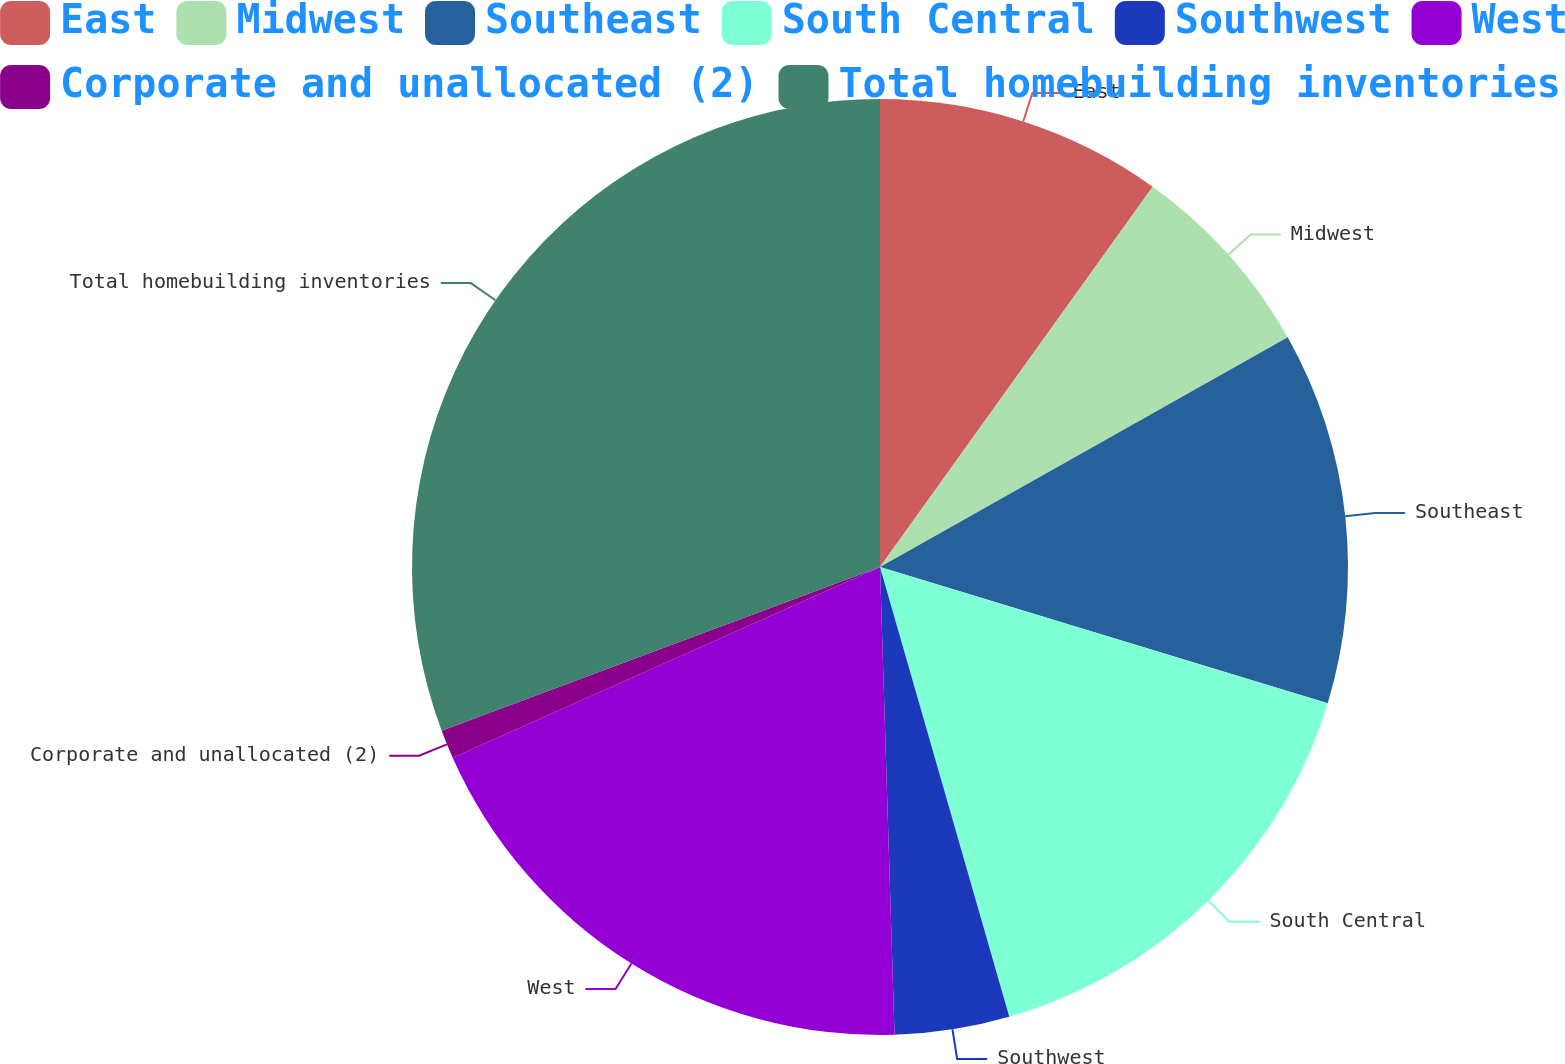<chart> <loc_0><loc_0><loc_500><loc_500><pie_chart><fcel>East<fcel>Midwest<fcel>Southeast<fcel>South Central<fcel>Southwest<fcel>West<fcel>Corporate and unallocated (2)<fcel>Total homebuilding inventories<nl><fcel>9.9%<fcel>6.93%<fcel>12.87%<fcel>15.84%<fcel>3.96%<fcel>18.81%<fcel>0.99%<fcel>30.69%<nl></chart> 